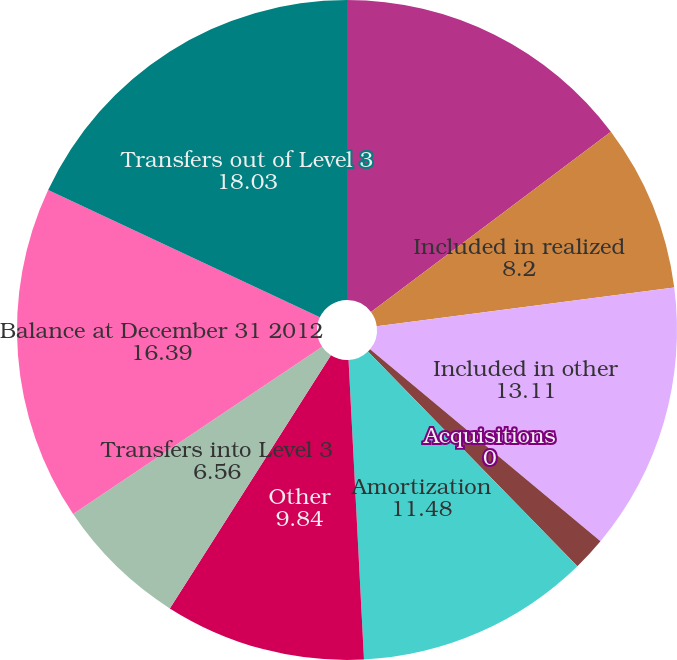Convert chart. <chart><loc_0><loc_0><loc_500><loc_500><pie_chart><fcel>Balance at January 1 2012<fcel>Included in realized<fcel>Included in other<fcel>Acquisitions<fcel>Sales<fcel>Amortization<fcel>Other<fcel>Transfers into Level 3<fcel>Balance at December 31 2012<fcel>Transfers out of Level 3<nl><fcel>14.75%<fcel>8.2%<fcel>13.11%<fcel>0.0%<fcel>1.64%<fcel>11.48%<fcel>9.84%<fcel>6.56%<fcel>16.39%<fcel>18.03%<nl></chart> 